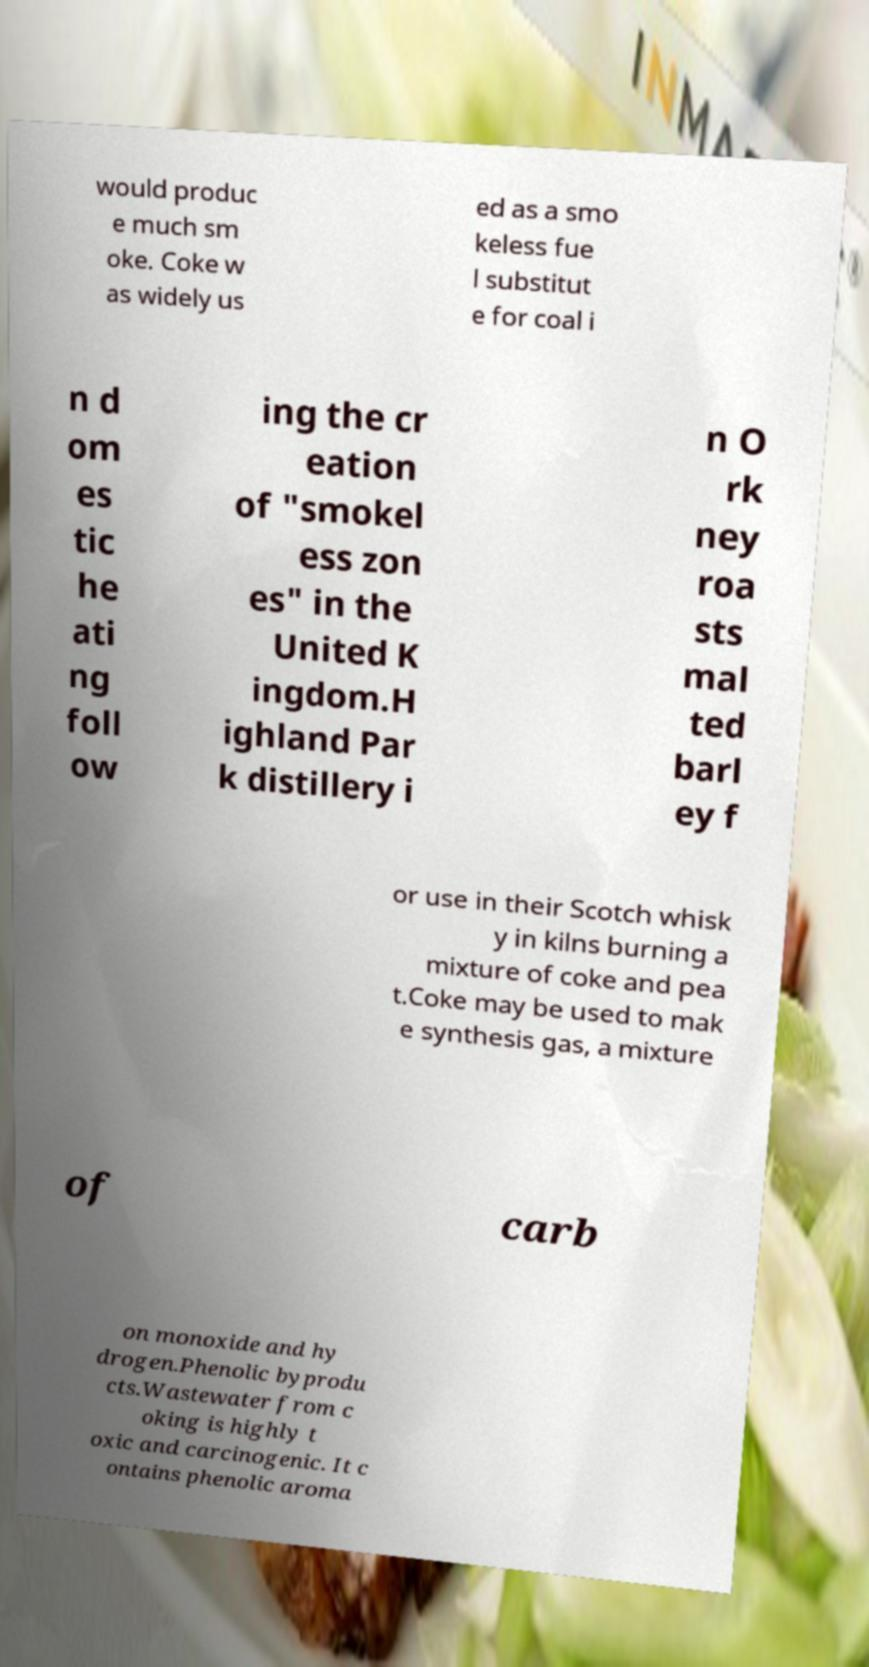Could you assist in decoding the text presented in this image and type it out clearly? would produc e much sm oke. Coke w as widely us ed as a smo keless fue l substitut e for coal i n d om es tic he ati ng foll ow ing the cr eation of "smokel ess zon es" in the United K ingdom.H ighland Par k distillery i n O rk ney roa sts mal ted barl ey f or use in their Scotch whisk y in kilns burning a mixture of coke and pea t.Coke may be used to mak e synthesis gas, a mixture of carb on monoxide and hy drogen.Phenolic byprodu cts.Wastewater from c oking is highly t oxic and carcinogenic. It c ontains phenolic aroma 